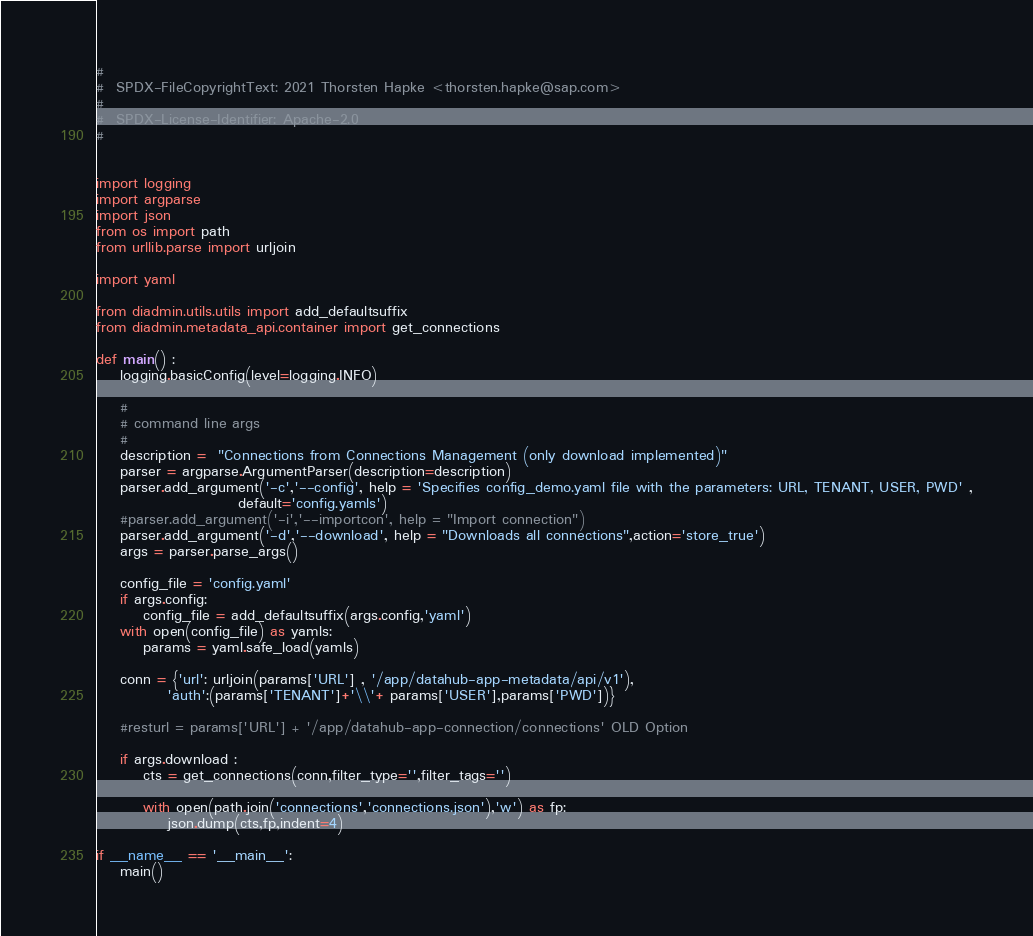Convert code to text. <code><loc_0><loc_0><loc_500><loc_500><_Python_>#
#  SPDX-FileCopyrightText: 2021 Thorsten Hapke <thorsten.hapke@sap.com>
#
#  SPDX-License-Identifier: Apache-2.0
#


import logging
import argparse
import json
from os import path
from urllib.parse import urljoin

import yaml

from diadmin.utils.utils import add_defaultsuffix
from diadmin.metadata_api.container import get_connections

def main() :
    logging.basicConfig(level=logging.INFO)

    #
    # command line args
    #
    description =  "Connections from Connections Management (only download implemented)"
    parser = argparse.ArgumentParser(description=description)
    parser.add_argument('-c','--config', help = 'Specifies config_demo.yaml file with the parameters: URL, TENANT, USER, PWD' ,
                        default='config.yamls')
    #parser.add_argument('-i','--importcon', help = "Import connection")
    parser.add_argument('-d','--download', help = "Downloads all connections",action='store_true')
    args = parser.parse_args()

    config_file = 'config.yaml'
    if args.config:
        config_file = add_defaultsuffix(args.config,'yaml')
    with open(config_file) as yamls:
        params = yaml.safe_load(yamls)

    conn = {'url': urljoin(params['URL'] , '/app/datahub-app-metadata/api/v1'),
            'auth':(params['TENANT']+'\\'+ params['USER'],params['PWD'])}

    #resturl = params['URL'] + '/app/datahub-app-connection/connections' OLD Option

    if args.download :
        cts = get_connections(conn,filter_type='',filter_tags='')

        with open(path.join('connections','connections.json'),'w') as fp:
            json.dump(cts,fp,indent=4)

if __name__ == '__main__':
    main()</code> 